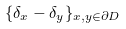Convert formula to latex. <formula><loc_0><loc_0><loc_500><loc_500>\{ \delta _ { x } - \delta _ { y } \} _ { x , y \in \partial D }</formula> 